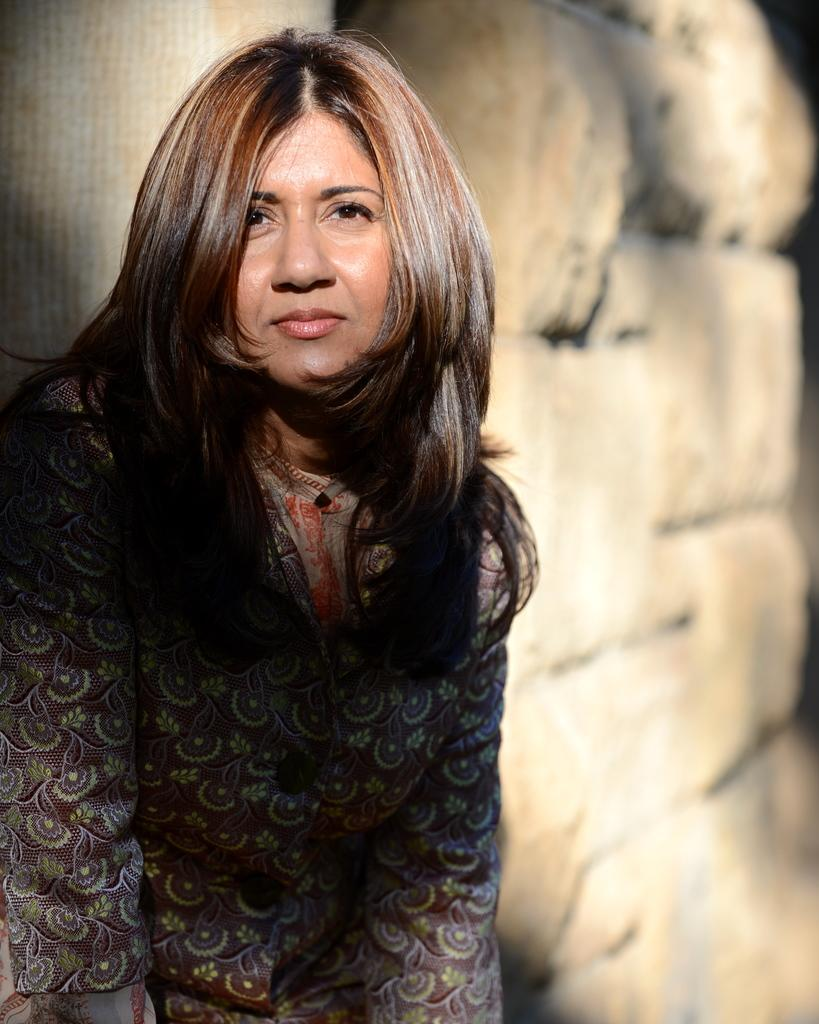Who is present in the image? There is a woman in the picture. What is the woman doing in the image? The woman is leaning against a wall. What is the woman's posture in the image? The woman is standing. Can you describe the woman's appearance in the image? The woman has long hair. What can be seen on the wall in the image? There are rocks on the wall in the image. What type of gold jewelry is the woman wearing in the image? There is no gold jewelry visible on the woman in the image. Is the woman engaged in a camping activity in the image? There is no indication of camping or any related activities in the image. 